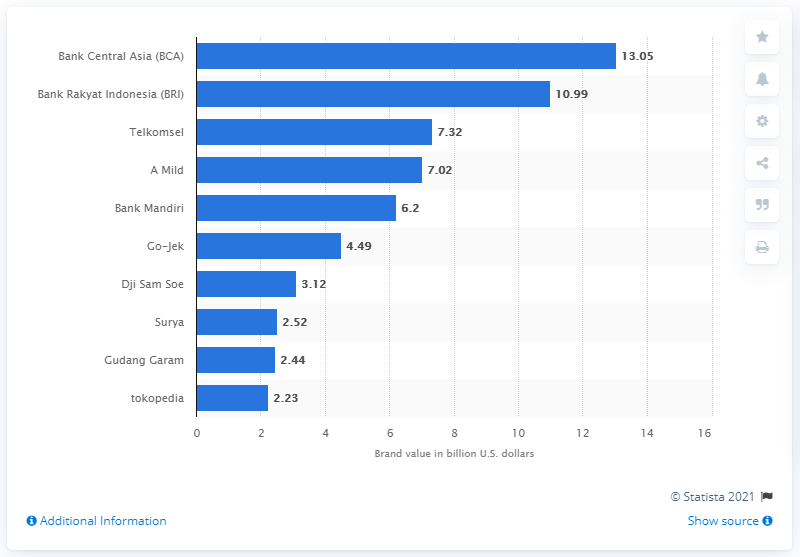What ride-hailing start-up had 88 percent growth in 2019? The chart in the image displays the brand value of various Indonesian companies in billion U.S. dollars, as of 2021, not the growth percentage in 2019. However, Go-Jek is featured on the chart with a brand value of approximately 4.49 billion U.S. dollars. 